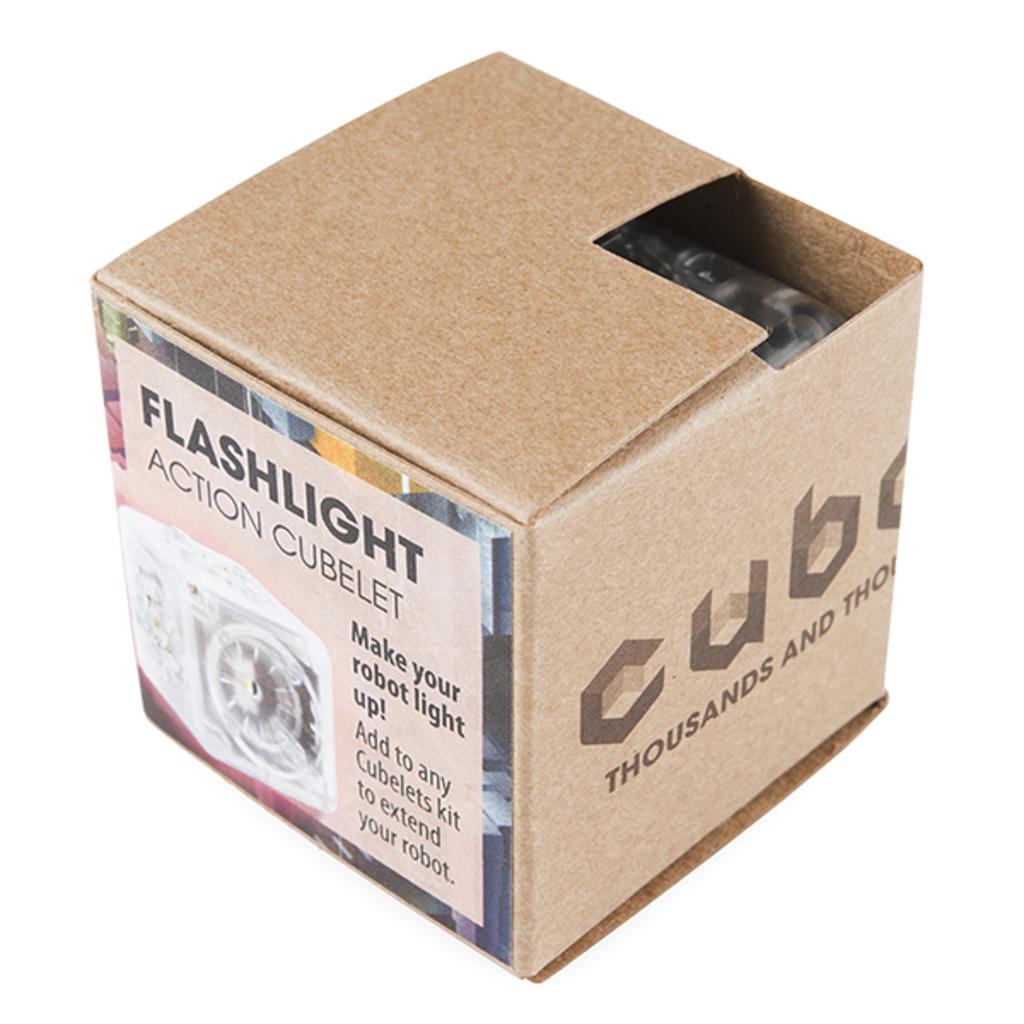What is the use of this product?
Offer a very short reply. Flashlight. What is the bold black word at the top?
Offer a terse response. Flashlight. 